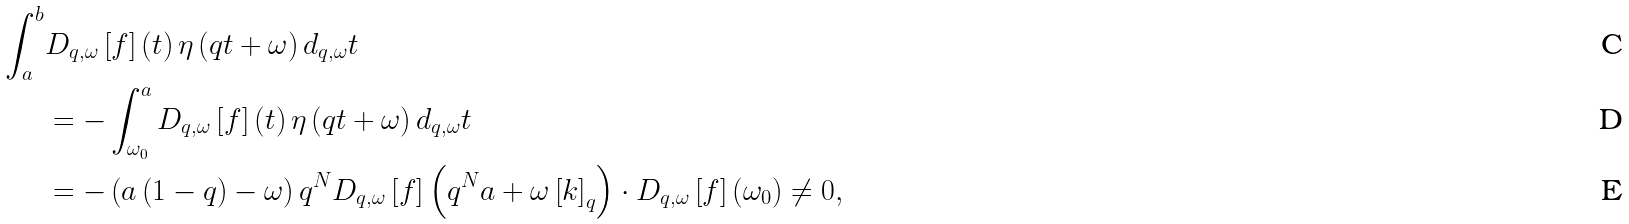<formula> <loc_0><loc_0><loc_500><loc_500>\int _ { a } ^ { b } & D _ { q , \omega } \left [ f \right ] \left ( t \right ) \eta \left ( q t + \omega \right ) d _ { q , \omega } t \\ & = - \int _ { \omega _ { 0 } } ^ { a } D _ { q , \omega } \left [ f \right ] \left ( t \right ) \eta \left ( q t + \omega \right ) d _ { q , \omega } t \\ & = - \left ( a \left ( 1 - q \right ) - \omega \right ) q ^ { N } D _ { q , \omega } \left [ f \right ] \left ( q ^ { N } a + \omega \left [ k \right ] _ { q } \right ) \cdot D _ { q , \omega } \left [ f \right ] \left ( \omega _ { 0 } \right ) \neq 0 ,</formula> 